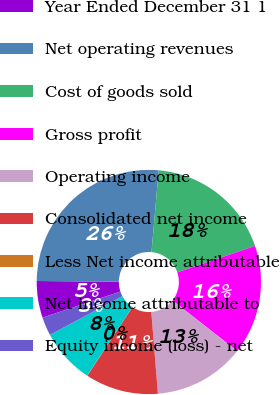Convert chart. <chart><loc_0><loc_0><loc_500><loc_500><pie_chart><fcel>Year Ended December 31 1<fcel>Net operating revenues<fcel>Cost of goods sold<fcel>Gross profit<fcel>Operating income<fcel>Consolidated net income<fcel>Less Net income attributable<fcel>Net income attributable to<fcel>Equity income (loss) - net<nl><fcel>5.29%<fcel>26.26%<fcel>18.39%<fcel>15.77%<fcel>13.15%<fcel>10.53%<fcel>0.04%<fcel>7.91%<fcel>2.66%<nl></chart> 